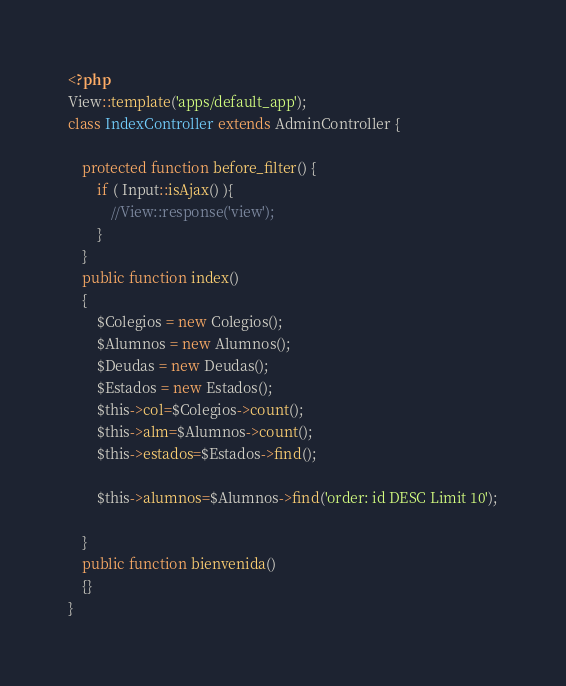Convert code to text. <code><loc_0><loc_0><loc_500><loc_500><_PHP_><?php
View::template('apps/default_app');
class IndexController extends AdminController {
	
	protected function before_filter() {
        if ( Input::isAjax() ){
			//View::response('view');
        }
    }
    public function index()
	{
		$Colegios = new Colegios();
		$Alumnos = new Alumnos();
		$Deudas = new Deudas();
		$Estados = new Estados();
		$this->col=$Colegios->count();
		$this->alm=$Alumnos->count();
		$this->estados=$Estados->find();

		$this->alumnos=$Alumnos->find('order: id DESC Limit 10');

	}
	public function bienvenida()
	{}	
}
</code> 